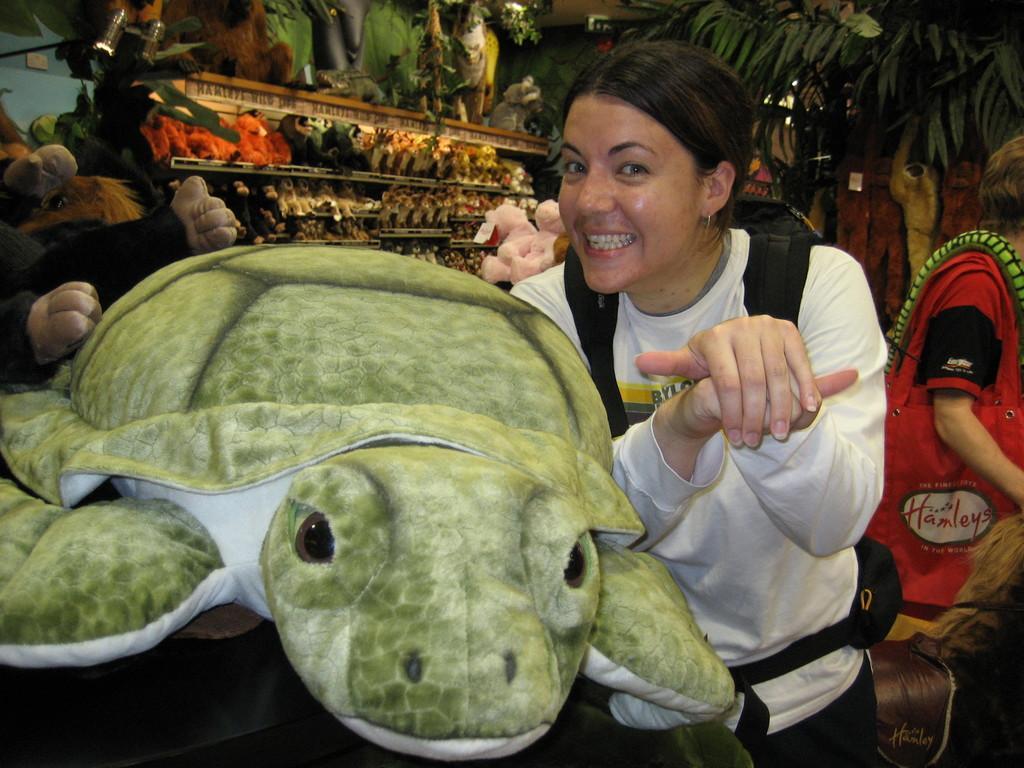Can you describe this image briefly? In this picture I can see a woman in front and I see a soft toy near to her and I see that she is smiling. In the background I see few more soft toys and I see few people. 